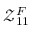Convert formula to latex. <formula><loc_0><loc_0><loc_500><loc_500>\mathcal { Z } _ { 1 1 } ^ { F }</formula> 